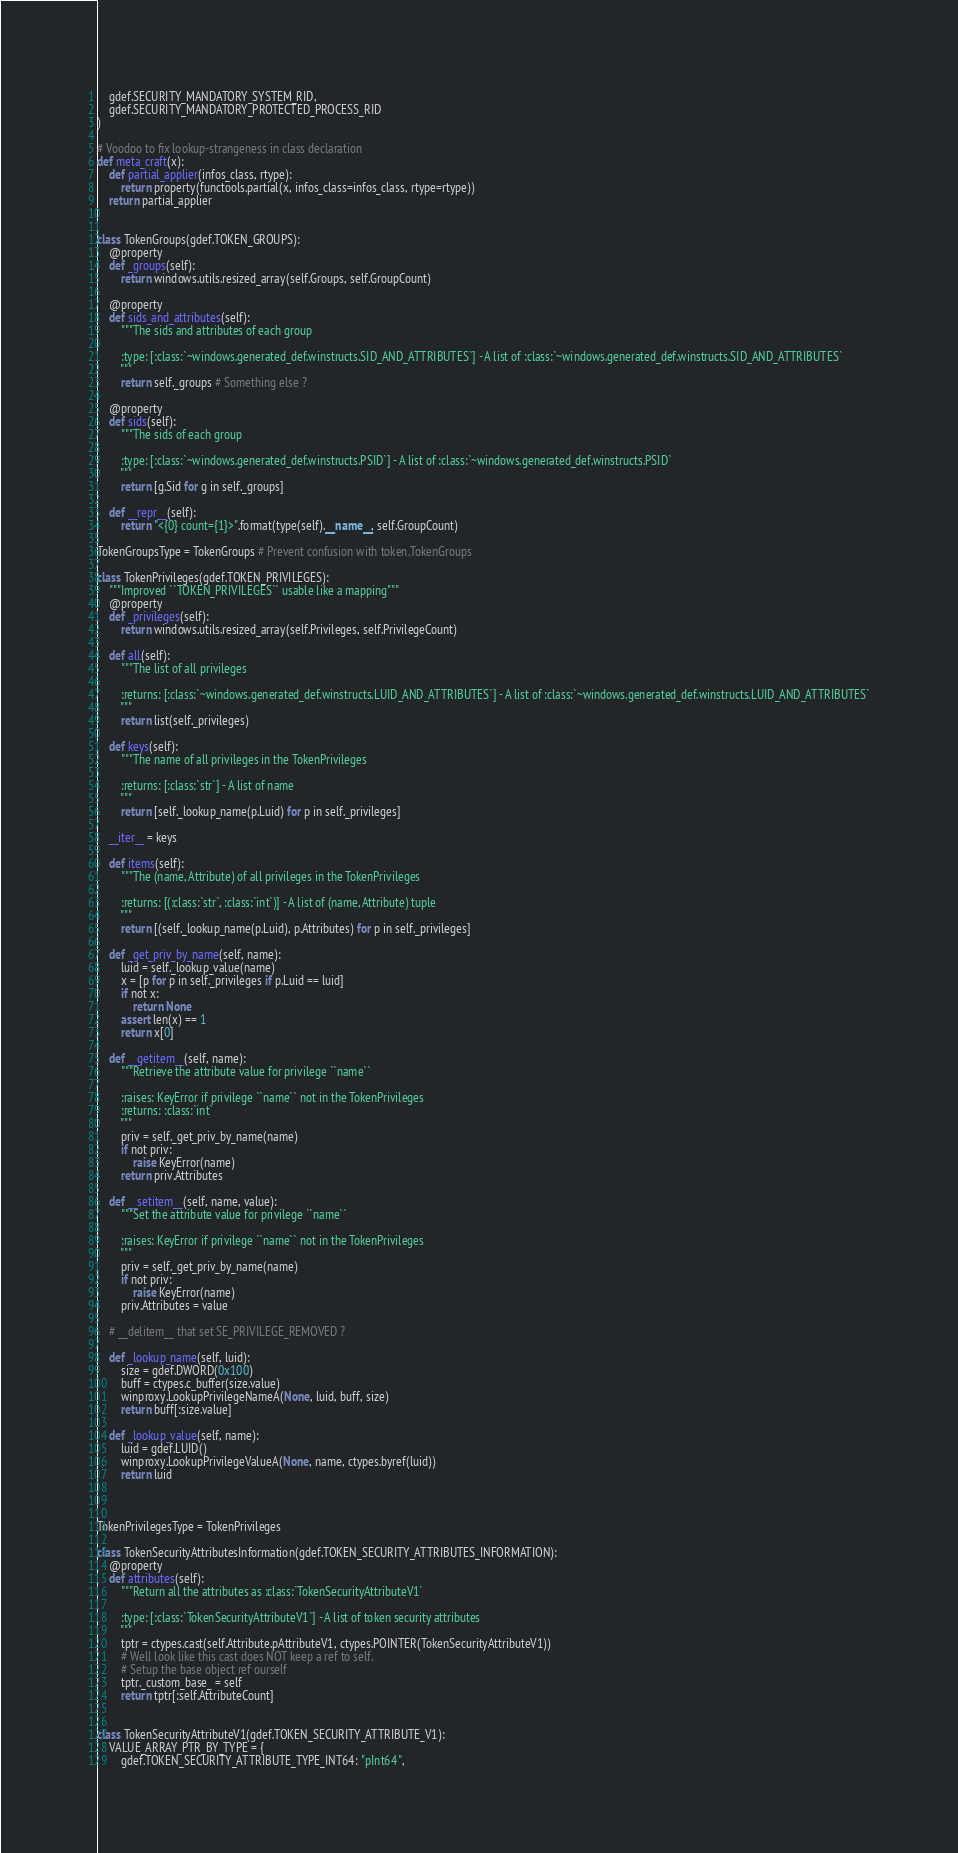<code> <loc_0><loc_0><loc_500><loc_500><_Python_>    gdef.SECURITY_MANDATORY_SYSTEM_RID,
    gdef.SECURITY_MANDATORY_PROTECTED_PROCESS_RID
)

# Voodoo to fix lookup-strangeness in class declaration
def meta_craft(x):
    def partial_applier(infos_class, rtype):
        return property(functools.partial(x, infos_class=infos_class, rtype=rtype))
    return partial_applier


class TokenGroups(gdef.TOKEN_GROUPS):
    @property
    def _groups(self):
        return windows.utils.resized_array(self.Groups, self.GroupCount)

    @property
    def sids_and_attributes(self):
        """The sids and attributes of each group

        :type: [:class:`~windows.generated_def.winstructs.SID_AND_ATTRIBUTES`] - A list of :class:`~windows.generated_def.winstructs.SID_AND_ATTRIBUTES`
        """
        return self._groups # Something else ?

    @property
    def sids(self):
        """The sids of each group

        :type: [:class:`~windows.generated_def.winstructs.PSID`] - A list of :class:`~windows.generated_def.winstructs.PSID`
        """
        return [g.Sid for g in self._groups]

    def __repr__(self):
        return "<{0} count={1}>".format(type(self).__name__, self.GroupCount)

TokenGroupsType = TokenGroups # Prevent confusion with token.TokenGroups

class TokenPrivileges(gdef.TOKEN_PRIVILEGES):
    """Improved ``TOKEN_PRIVILEGES`` usable like a mapping"""
    @property
    def _privileges(self):
        return windows.utils.resized_array(self.Privileges, self.PrivilegeCount)

    def all(self):
        """The list of all privileges

        :returns: [:class:`~windows.generated_def.winstructs.LUID_AND_ATTRIBUTES`] - A list of :class:`~windows.generated_def.winstructs.LUID_AND_ATTRIBUTES`
        """
        return list(self._privileges)

    def keys(self):
        """The name of all privileges in the TokenPrivileges

        :returns: [:class:`str`] - A list of name
        """
        return [self._lookup_name(p.Luid) for p in self._privileges]

    __iter__ = keys

    def items(self):
        """The (name, Attribute) of all privileges in the TokenPrivileges

        :returns: [(:class:`str`, :class:`int`)] - A list of (name, Attribute) tuple
        """
        return [(self._lookup_name(p.Luid), p.Attributes) for p in self._privileges]

    def _get_priv_by_name(self, name):
        luid = self._lookup_value(name)
        x = [p for p in self._privileges if p.Luid == luid]
        if not x:
            return None
        assert len(x) == 1
        return x[0]

    def __getitem__(self, name):
        """Retrieve the attribute value for privilege ``name``

        :raises: KeyError if privilege ``name`` not in the TokenPrivileges
        :returns: :class:`int`
        """
        priv = self._get_priv_by_name(name)
        if not priv:
            raise KeyError(name)
        return priv.Attributes

    def __setitem__(self, name, value):
        """Set the attribute value for privilege ``name``

        :raises: KeyError if privilege ``name`` not in the TokenPrivileges
        """
        priv = self._get_priv_by_name(name)
        if not priv:
            raise KeyError(name)
        priv.Attributes = value

    # __delitem__ that set SE_PRIVILEGE_REMOVED ?

    def _lookup_name(self, luid):
        size = gdef.DWORD(0x100)
        buff = ctypes.c_buffer(size.value)
        winproxy.LookupPrivilegeNameA(None, luid, buff, size)
        return buff[:size.value]

    def _lookup_value(self, name):
        luid = gdef.LUID()
        winproxy.LookupPrivilegeValueA(None, name, ctypes.byref(luid))
        return luid



TokenPrivilegesType = TokenPrivileges

class TokenSecurityAttributesInformation(gdef.TOKEN_SECURITY_ATTRIBUTES_INFORMATION):
    @property
    def attributes(self):
        """Return all the attributes as :class:`TokenSecurityAttributeV1`

        :type: [:class:`TokenSecurityAttributeV1`] - A list of token security attributes
        """
        tptr = ctypes.cast(self.Attribute.pAttributeV1, ctypes.POINTER(TokenSecurityAttributeV1))
        # Well look like this cast does NOT keep a ref to self.
        # Setup the base object ref ourself
        tptr._custom_base_ = self
        return tptr[:self.AttributeCount]


class TokenSecurityAttributeV1(gdef.TOKEN_SECURITY_ATTRIBUTE_V1):
    VALUE_ARRAY_PTR_BY_TYPE = {
        gdef.TOKEN_SECURITY_ATTRIBUTE_TYPE_INT64: "pInt64",</code> 